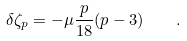<formula> <loc_0><loc_0><loc_500><loc_500>\delta \zeta _ { p } = - \mu \frac { p } { 1 8 } ( p - 3 ) \quad .</formula> 